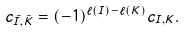Convert formula to latex. <formula><loc_0><loc_0><loc_500><loc_500>c _ { \bar { I } , \bar { K } } = ( - 1 ) ^ { \ell ( I ) - \ell ( K ) } c _ { I , K } .</formula> 